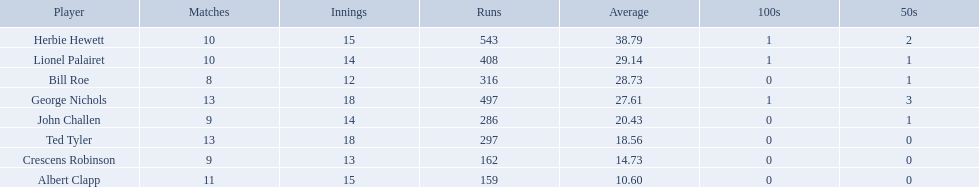Who are all of the players? Herbie Hewett, Lionel Palairet, Bill Roe, George Nichols, John Challen, Ted Tyler, Crescens Robinson, Albert Clapp. How many innings did they play in? 15, 14, 12, 18, 14, 18, 13, 15. Which player was in fewer than 13 innings? Bill Roe. Who are the players in somerset county cricket club in 1890? Herbie Hewett, Lionel Palairet, Bill Roe, George Nichols, John Challen, Ted Tyler, Crescens Robinson, Albert Clapp. Who is the only player to play less than 13 innings? Bill Roe. I'm looking to parse the entire table for insights. Could you assist me with that? {'header': ['Player', 'Matches', 'Innings', 'Runs', 'Average', '100s', '50s'], 'rows': [['Herbie Hewett', '10', '15', '543', '38.79', '1', '2'], ['Lionel Palairet', '10', '14', '408', '29.14', '1', '1'], ['Bill Roe', '8', '12', '316', '28.73', '0', '1'], ['George Nichols', '13', '18', '497', '27.61', '1', '3'], ['John Challen', '9', '14', '286', '20.43', '0', '1'], ['Ted Tyler', '13', '18', '297', '18.56', '0', '0'], ['Crescens Robinson', '9', '13', '162', '14.73', '0', '0'], ['Albert Clapp', '11', '15', '159', '10.60', '0', '0']]} Which players played in 10 or fewer matches? Herbie Hewett, Lionel Palairet, Bill Roe, John Challen, Crescens Robinson. Of these, which played in only 12 innings? Bill Roe. Who are the members of somerset county cricket club in 1890? Herbie Hewett, Lionel Palairet, Bill Roe, George Nichols, John Challen, Ted Tyler, Crescens Robinson, Albert Clapp. Who is the sole member to participate in fewer than 13 innings? Bill Roe. Who are all the athletes? Herbie Hewett, Lionel Palairet, Bill Roe, George Nichols, John Challen, Ted Tyler, Crescens Robinson, Albert Clapp. How many innings did they compete in? 15, 14, 12, 18, 14, 18, 13, 15. Which player was involved in less than 13 innings? Bill Roe. Who are all the participants? Herbie Hewett, Lionel Palairet, Bill Roe, George Nichols, John Challen, Ted Tyler, Crescens Robinson, Albert Clapp. In how many innings did they participate? 15, 14, 12, 18, 14, 18, 13, 15. Which player took part in less than 13 innings? Bill Roe. Can you list all the players? Herbie Hewett, Lionel Palairet, Bill Roe, George Nichols, John Challen, Ted Tyler, Crescens Robinson, Albert Clapp. How many innings did each player play? 15, 14, 12, 18, 14, 18, 13, 15. Who played in under 13 innings? Bill Roe. What are the names of all the players? Herbie Hewett, Lionel Palairet, Bill Roe, George Nichols, John Challen, Ted Tyler, Crescens Robinson, Albert Clapp. What is the number of innings they played in? 15, 14, 12, 18, 14, 18, 13, 15. Identify the player who participated in fewer than 13 innings.? Bill Roe. 